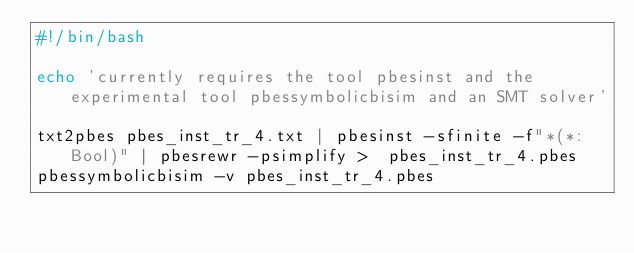Convert code to text. <code><loc_0><loc_0><loc_500><loc_500><_Bash_>#!/bin/bash

echo 'currently requires the tool pbesinst and the experimental tool pbessymbolicbisim and an SMT solver'

txt2pbes pbes_inst_tr_4.txt | pbesinst -sfinite -f"*(*:Bool)" | pbesrewr -psimplify >  pbes_inst_tr_4.pbes
pbessymbolicbisim -v pbes_inst_tr_4.pbes 
</code> 